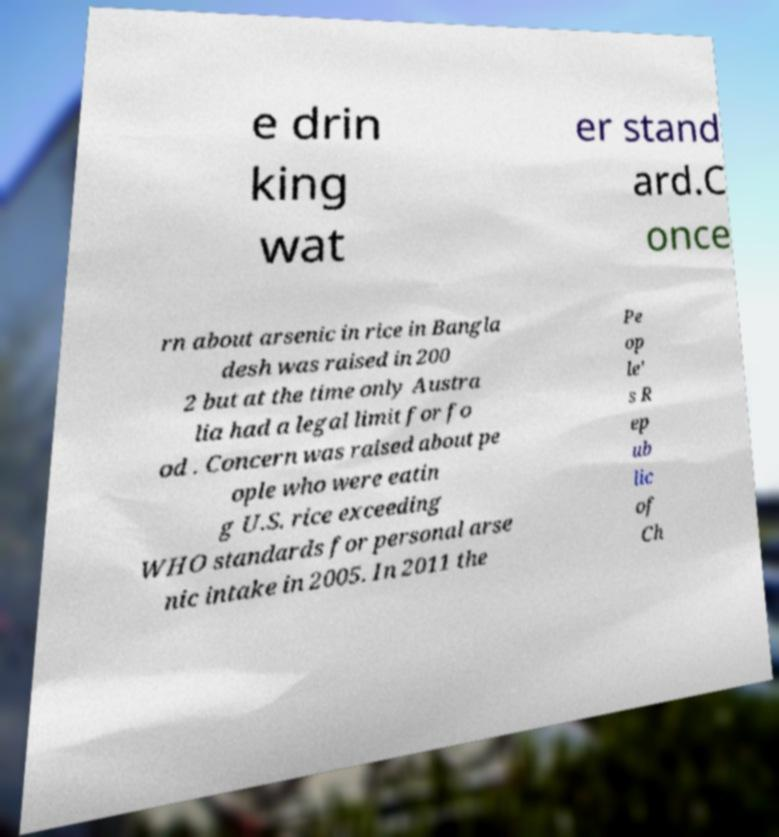There's text embedded in this image that I need extracted. Can you transcribe it verbatim? e drin king wat er stand ard.C once rn about arsenic in rice in Bangla desh was raised in 200 2 but at the time only Austra lia had a legal limit for fo od . Concern was raised about pe ople who were eatin g U.S. rice exceeding WHO standards for personal arse nic intake in 2005. In 2011 the Pe op le' s R ep ub lic of Ch 